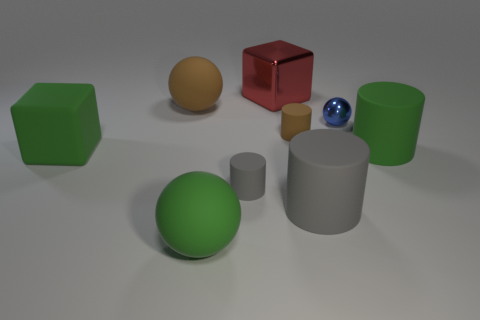Subtract all tiny gray cylinders. How many cylinders are left? 3 Subtract 1 cubes. How many cubes are left? 1 Subtract all green blocks. How many blocks are left? 1 Add 1 big cubes. How many objects exist? 10 Subtract all green cylinders. How many cyan blocks are left? 0 Subtract all tiny gray things. Subtract all large green matte things. How many objects are left? 5 Add 6 green spheres. How many green spheres are left? 7 Add 2 small green balls. How many small green balls exist? 2 Subtract 1 gray cylinders. How many objects are left? 8 Subtract all cubes. How many objects are left? 7 